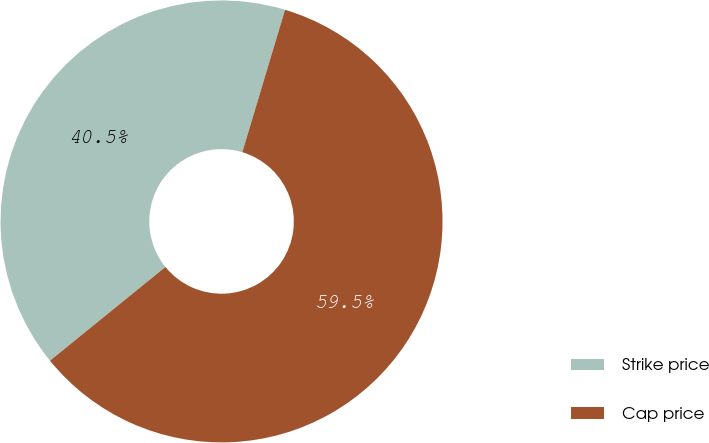<chart> <loc_0><loc_0><loc_500><loc_500><pie_chart><fcel>Strike price<fcel>Cap price<nl><fcel>40.49%<fcel>59.51%<nl></chart> 